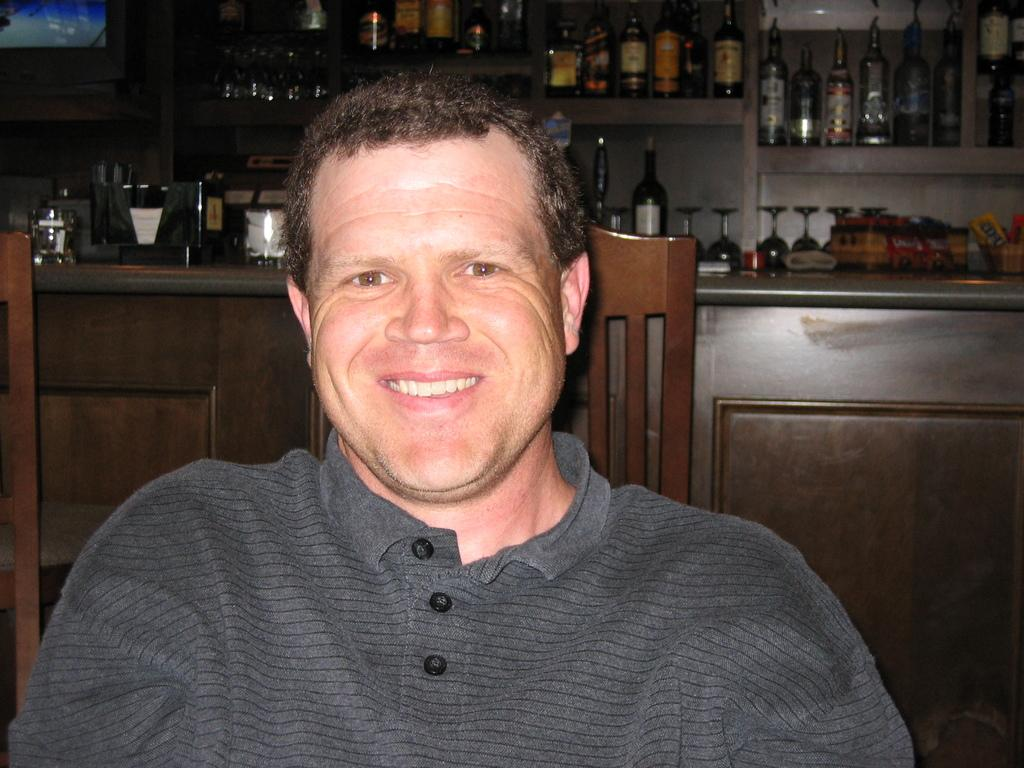What is the main subject of the image? The main subject of the image is a man. What is the man wearing in the image? The man is wearing a t-shirt in the image. What is the man's position in the image? The man is sitting on a chair in the image. What can be seen in the background of the image? There are bottles and glasses on racks in the background of the image. How does the man compare to the farmer in the image? There is no farmer present in the image, so it is not possible to make a comparison. 